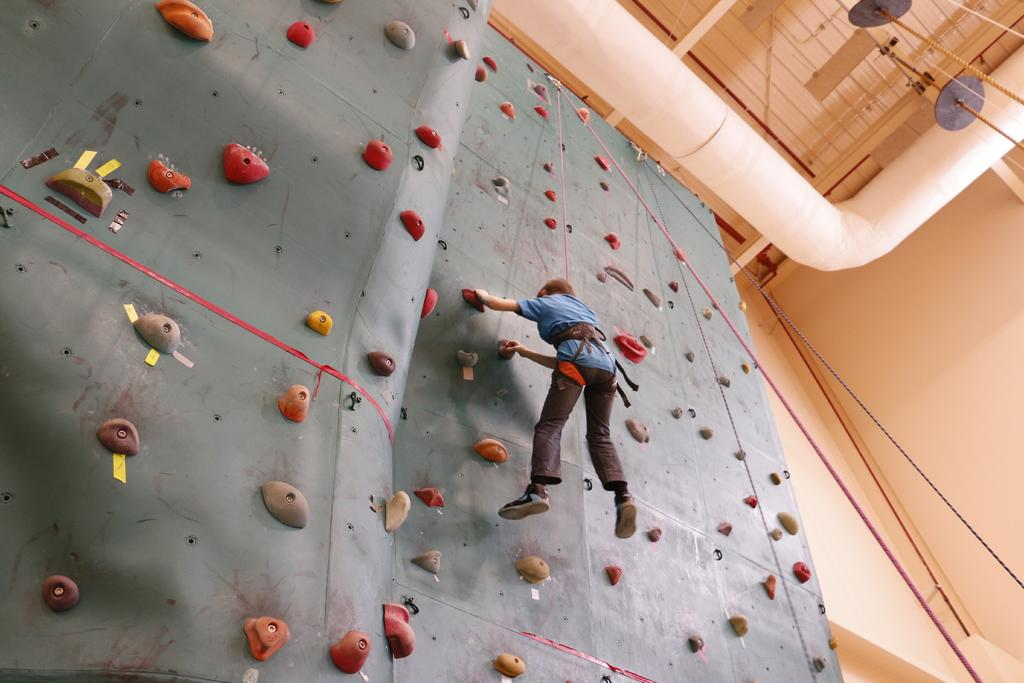What is the main feature in the center of the image? There is a climbing wall in the center of the image. Who or what is also in the center of the image? A person is in the center of the image. What can be seen in the background of the image? There is a wall in the background of the image. What is present at the top of the image? Pipes and ropes are visible at the top of the image. What type of brass instrument is being played by the person on the climbing wall? There is no brass instrument present in the image; the person is focused on climbing the wall. 